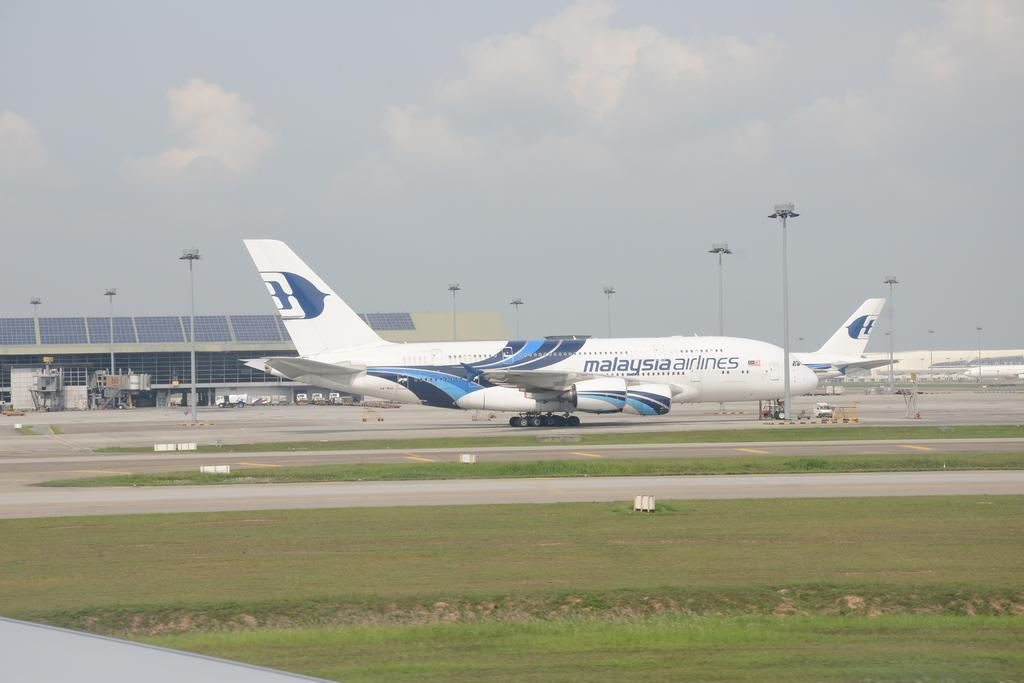What is unusual about the location of the aeroplane in the image? The aeroplane is on the road, which is an unusual place for an aeroplane. What objects can be seen in the image that are typically used for supporting or guiding? There are poles in the image. What types of vehicles can be seen in the image? There are vehicles in the image. What type of structure is present in the image? There is a shed in the image. What type of vegetation is visible in the image? There is grass in the image. What is visible in the background of the image? Sky is visible in the background of the image, and clouds are present in the sky. What type of worm can be seen crawling on the aeroplane in the image? There is no worm present in the image; it only features an aeroplane on the road, poles, vehicles, a shed, grass, and the sky. 